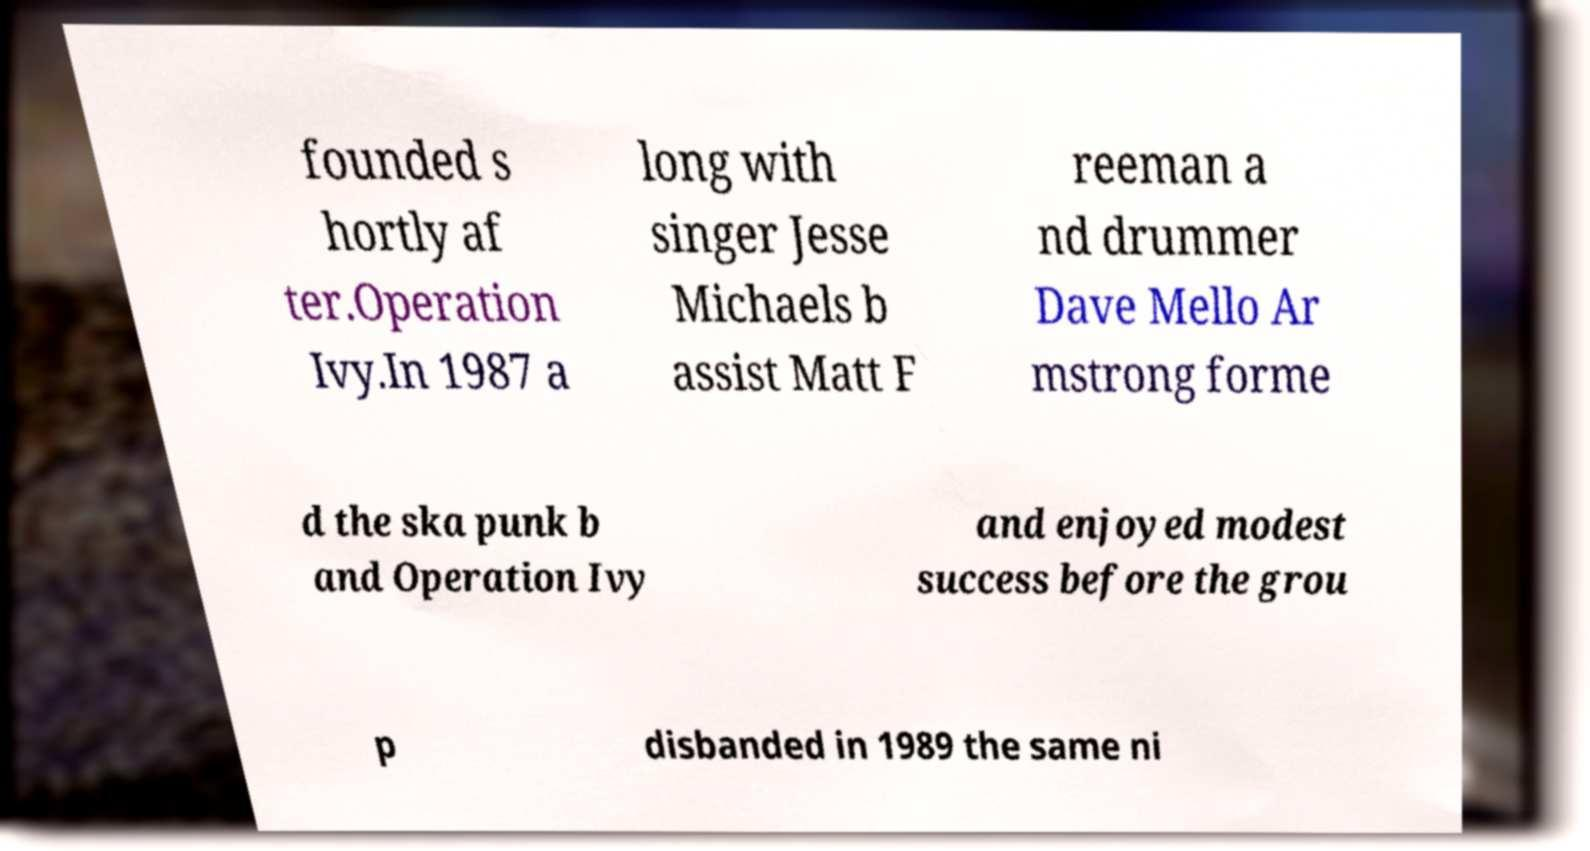Please read and relay the text visible in this image. What does it say? founded s hortly af ter.Operation Ivy.In 1987 a long with singer Jesse Michaels b assist Matt F reeman a nd drummer Dave Mello Ar mstrong forme d the ska punk b and Operation Ivy and enjoyed modest success before the grou p disbanded in 1989 the same ni 